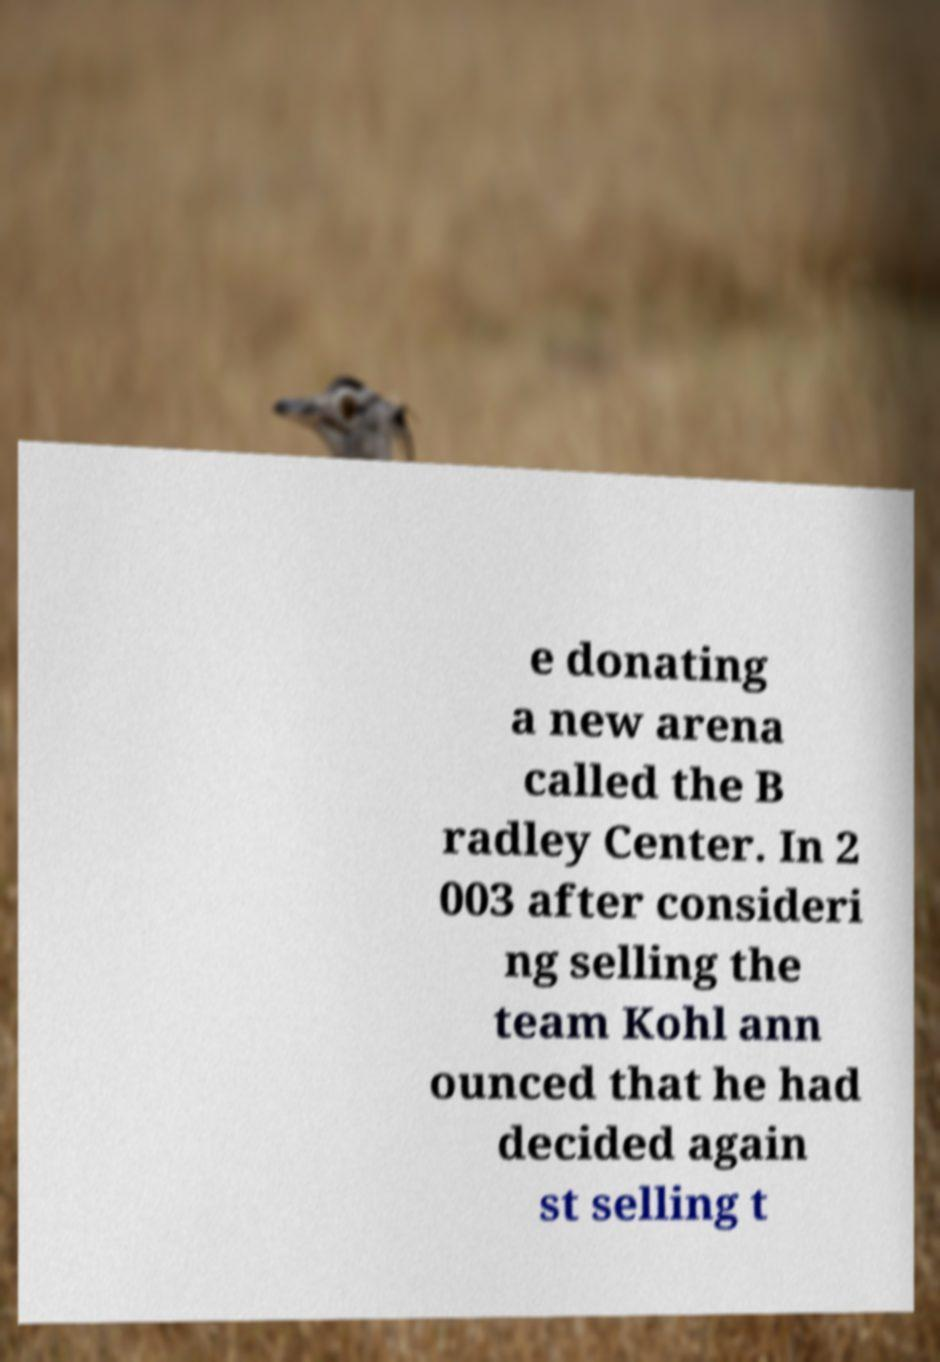Can you read and provide the text displayed in the image?This photo seems to have some interesting text. Can you extract and type it out for me? e donating a new arena called the B radley Center. In 2 003 after consideri ng selling the team Kohl ann ounced that he had decided again st selling t 